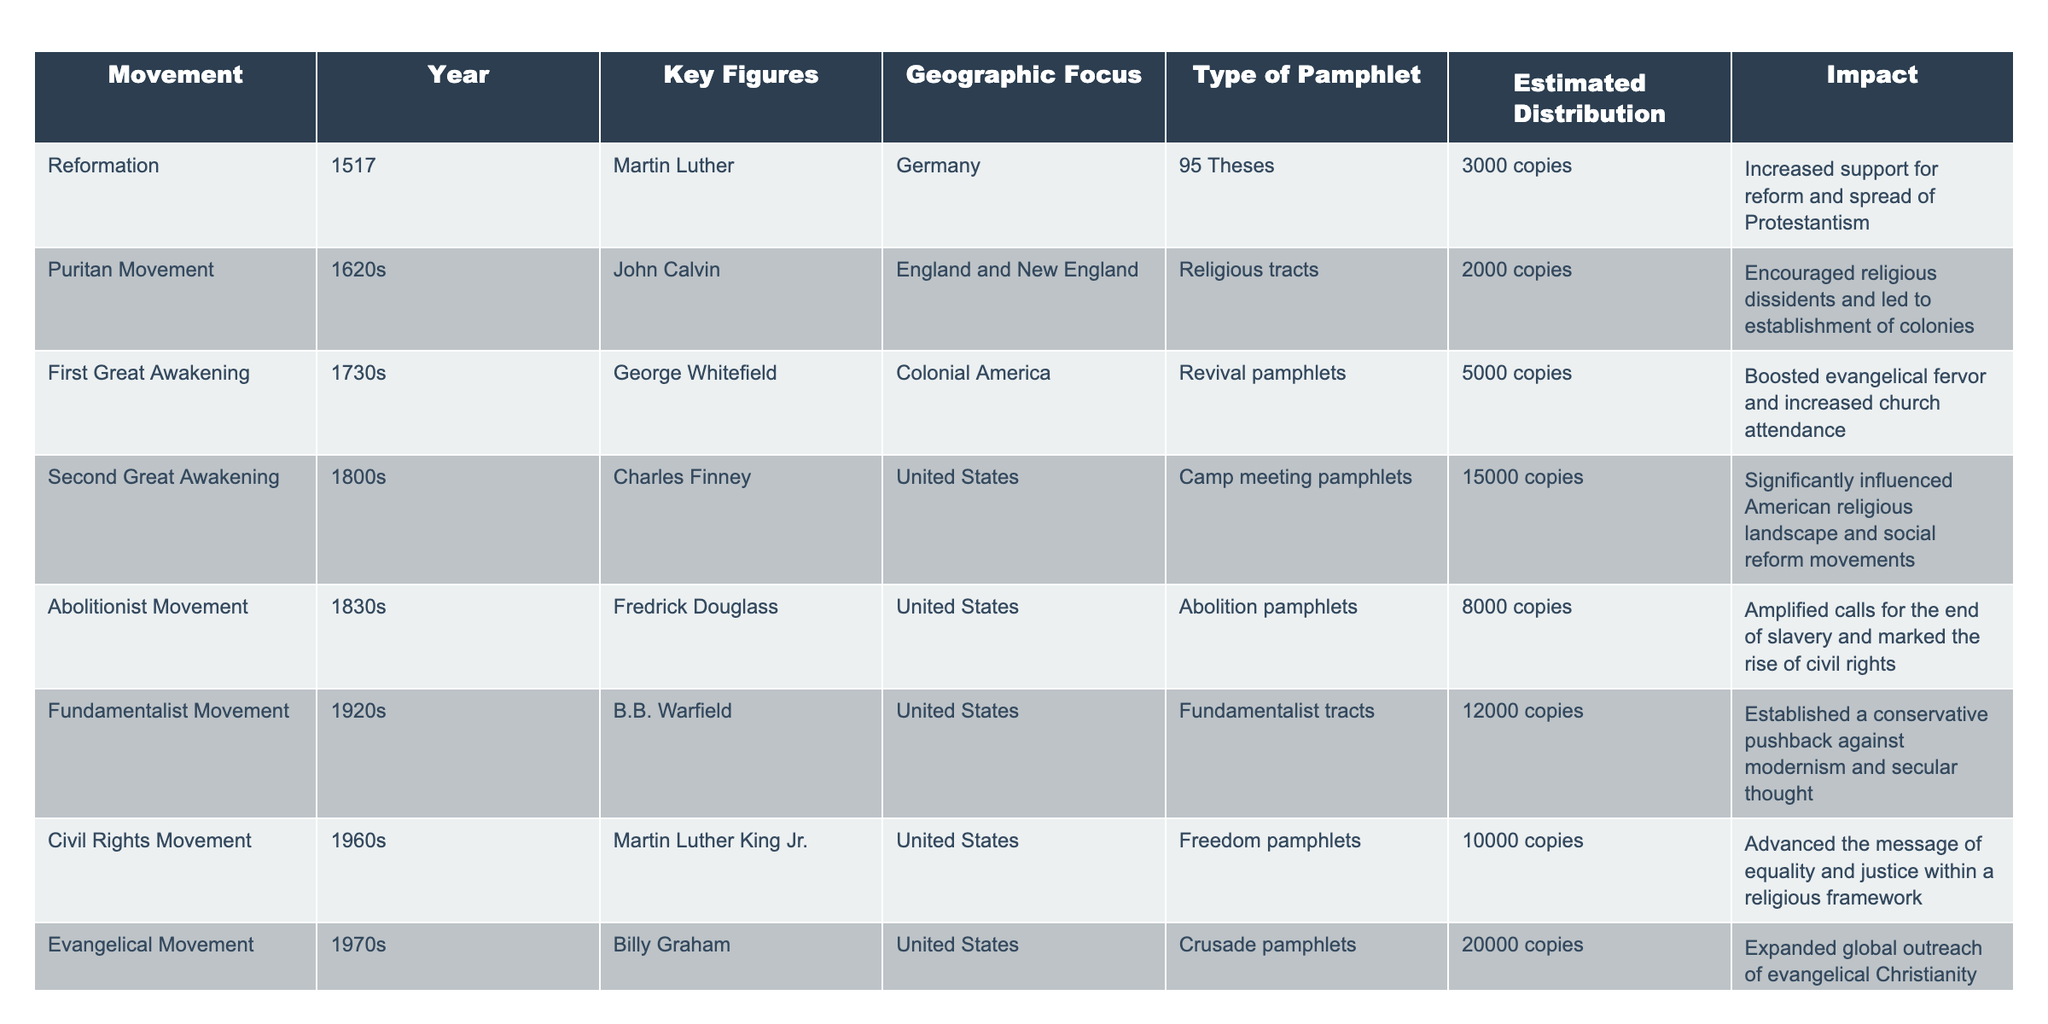What was the estimated distribution of pamphlets during the Second Great Awakening? The table shows the estimated distribution for the Second Great Awakening as 15,000 copies.
Answer: 15,000 copies Who were the key figures in the Reformation? According to the table, Martin Luther is listed as the key figure during the Reformation.
Answer: Martin Luther What type of pamphlet was primarily distributed during the Abolitionist Movement? The table specifies that abolition pamphlets were distributed during the Abolitionist Movement.
Answer: Abolition pamphlets Which movement had the highest estimated distribution of pamphlets? By comparing all the estimated distributions, the Evangelical Movement shows the highest at 20,000 copies.
Answer: 20,000 copies What impact did the Civil Rights Movement's pamphlets have? The table indicates that the Civil Rights Movement's pamphlets advanced the message of equality and justice within a religious framework.
Answer: Advanced equality and justice message How many copies were distributed in total for both the First Great Awakening and the New Age Movement? The First Great Awakening distributed 5,000 copies and the New Age Movement distributed 15,000 copies. Adding these gives 20,000 copies in total.
Answer: 20,000 copies Did the Fundamentalist Movement have a greater impact than the Puritan Movement? The table shows the Fundamentalist Movement established a conservative pushback against modernism while the Puritan Movement encouraged religious dissidents, making it a more significant impact contextually.
Answer: Yes, more impact What is the average estimated distribution of pamphlets across all movements listed? The estimated distributions are: 3,000; 2,000; 5,000; 15,000; 8,000; 12,000; 10,000; 20,000; 15,000. Summing these gives 75,000, and dividing by the number of movements (9) gives an average of about 8,333.
Answer: 8,333 What geographic focus was common between the First and Second Great Awakenings? Both movements' geographic focus was on the United States, according to the table.
Answer: United States True or False: The Puritan Movement distributed more pamphlets than the Fundamentalist Movement. The Puritan Movement distributed 2,000 copies, whereas the Fundamentalist Movement distributed 12,000 copies; therefore, the statement is false.
Answer: False 